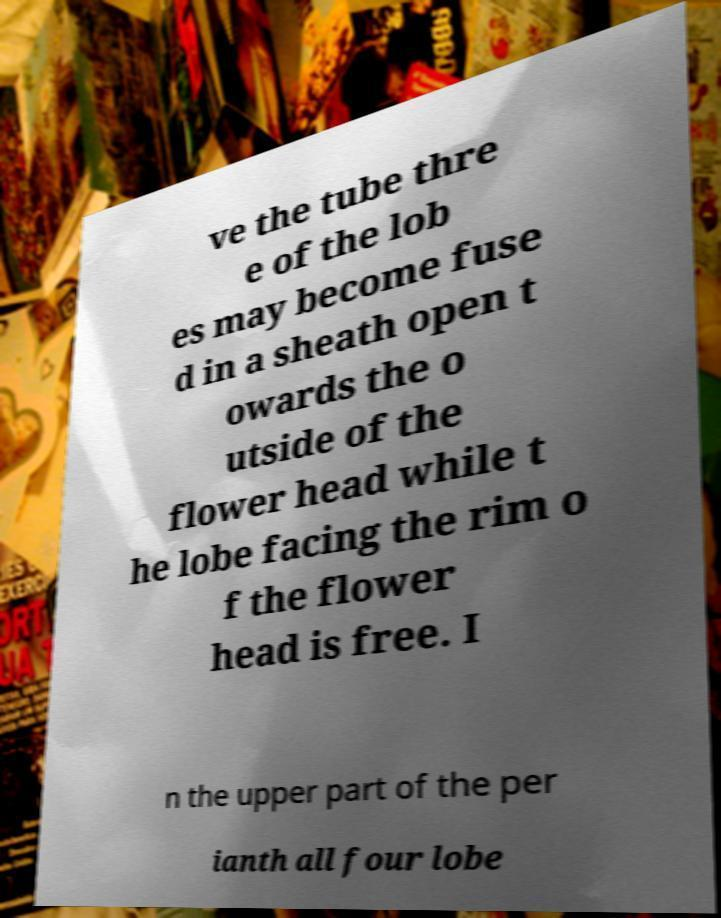I need the written content from this picture converted into text. Can you do that? ve the tube thre e of the lob es may become fuse d in a sheath open t owards the o utside of the flower head while t he lobe facing the rim o f the flower head is free. I n the upper part of the per ianth all four lobe 